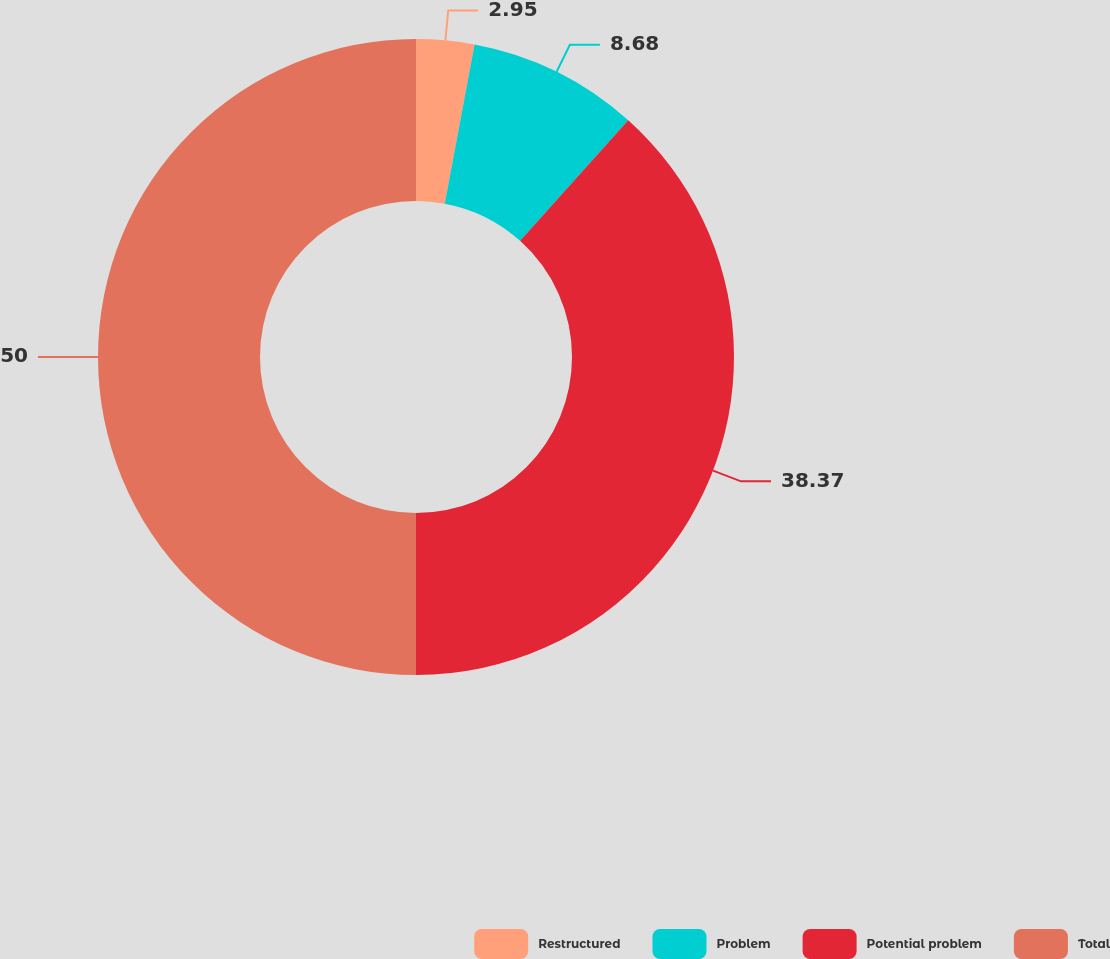Convert chart to OTSL. <chart><loc_0><loc_0><loc_500><loc_500><pie_chart><fcel>Restructured<fcel>Problem<fcel>Potential problem<fcel>Total<nl><fcel>2.95%<fcel>8.68%<fcel>38.37%<fcel>50.0%<nl></chart> 